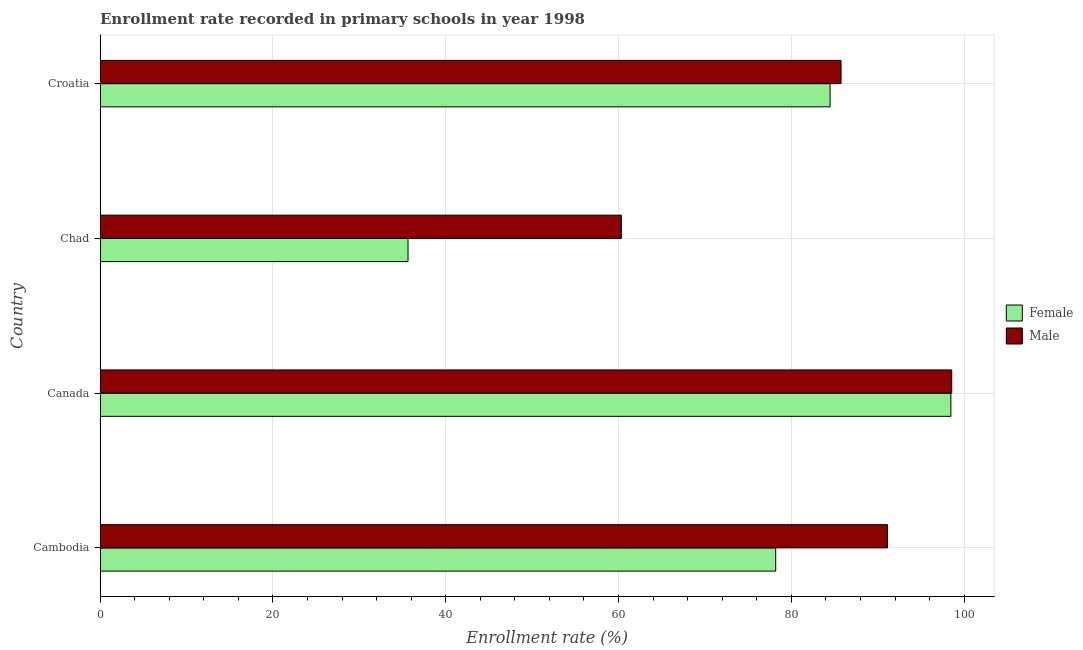How many groups of bars are there?
Make the answer very short. 4. How many bars are there on the 2nd tick from the top?
Provide a succinct answer. 2. What is the label of the 2nd group of bars from the top?
Your answer should be very brief. Chad. What is the enrollment rate of female students in Cambodia?
Your answer should be compact. 78.18. Across all countries, what is the maximum enrollment rate of male students?
Your response must be concise. 98.55. Across all countries, what is the minimum enrollment rate of female students?
Give a very brief answer. 35.64. In which country was the enrollment rate of male students maximum?
Your response must be concise. Canada. In which country was the enrollment rate of female students minimum?
Your response must be concise. Chad. What is the total enrollment rate of female students in the graph?
Offer a terse response. 296.76. What is the difference between the enrollment rate of male students in Cambodia and that in Chad?
Your response must be concise. 30.8. What is the difference between the enrollment rate of female students in Canada and the enrollment rate of male students in Cambodia?
Provide a succinct answer. 7.33. What is the average enrollment rate of male students per country?
Offer a terse response. 83.94. What is the difference between the enrollment rate of male students and enrollment rate of female students in Croatia?
Your answer should be compact. 1.27. In how many countries, is the enrollment rate of female students greater than 68 %?
Your response must be concise. 3. What is the ratio of the enrollment rate of male students in Cambodia to that in Croatia?
Your answer should be compact. 1.06. Is the difference between the enrollment rate of female students in Cambodia and Croatia greater than the difference between the enrollment rate of male students in Cambodia and Croatia?
Your response must be concise. No. What is the difference between the highest and the second highest enrollment rate of female students?
Your answer should be compact. 13.98. What is the difference between the highest and the lowest enrollment rate of female students?
Your response must be concise. 62.82. What does the 1st bar from the top in Cambodia represents?
Provide a short and direct response. Male. What does the 2nd bar from the bottom in Chad represents?
Ensure brevity in your answer.  Male. How many countries are there in the graph?
Give a very brief answer. 4. Where does the legend appear in the graph?
Your answer should be very brief. Center right. What is the title of the graph?
Keep it short and to the point. Enrollment rate recorded in primary schools in year 1998. What is the label or title of the X-axis?
Offer a very short reply. Enrollment rate (%). What is the label or title of the Y-axis?
Your answer should be compact. Country. What is the Enrollment rate (%) of Female in Cambodia?
Your answer should be compact. 78.18. What is the Enrollment rate (%) in Male in Cambodia?
Your answer should be very brief. 91.13. What is the Enrollment rate (%) of Female in Canada?
Ensure brevity in your answer.  98.46. What is the Enrollment rate (%) in Male in Canada?
Offer a very short reply. 98.55. What is the Enrollment rate (%) in Female in Chad?
Provide a short and direct response. 35.64. What is the Enrollment rate (%) in Male in Chad?
Offer a very short reply. 60.32. What is the Enrollment rate (%) of Female in Croatia?
Offer a terse response. 84.48. What is the Enrollment rate (%) in Male in Croatia?
Your answer should be very brief. 85.75. Across all countries, what is the maximum Enrollment rate (%) in Female?
Make the answer very short. 98.46. Across all countries, what is the maximum Enrollment rate (%) of Male?
Provide a succinct answer. 98.55. Across all countries, what is the minimum Enrollment rate (%) in Female?
Offer a terse response. 35.64. Across all countries, what is the minimum Enrollment rate (%) of Male?
Keep it short and to the point. 60.32. What is the total Enrollment rate (%) in Female in the graph?
Provide a short and direct response. 296.76. What is the total Enrollment rate (%) of Male in the graph?
Offer a terse response. 335.75. What is the difference between the Enrollment rate (%) of Female in Cambodia and that in Canada?
Ensure brevity in your answer.  -20.27. What is the difference between the Enrollment rate (%) of Male in Cambodia and that in Canada?
Provide a short and direct response. -7.43. What is the difference between the Enrollment rate (%) in Female in Cambodia and that in Chad?
Offer a terse response. 42.55. What is the difference between the Enrollment rate (%) in Male in Cambodia and that in Chad?
Provide a succinct answer. 30.8. What is the difference between the Enrollment rate (%) in Female in Cambodia and that in Croatia?
Provide a short and direct response. -6.3. What is the difference between the Enrollment rate (%) in Male in Cambodia and that in Croatia?
Your answer should be compact. 5.38. What is the difference between the Enrollment rate (%) in Female in Canada and that in Chad?
Provide a short and direct response. 62.82. What is the difference between the Enrollment rate (%) of Male in Canada and that in Chad?
Your answer should be compact. 38.23. What is the difference between the Enrollment rate (%) of Female in Canada and that in Croatia?
Offer a terse response. 13.98. What is the difference between the Enrollment rate (%) in Male in Canada and that in Croatia?
Ensure brevity in your answer.  12.81. What is the difference between the Enrollment rate (%) in Female in Chad and that in Croatia?
Your answer should be very brief. -48.84. What is the difference between the Enrollment rate (%) in Male in Chad and that in Croatia?
Your answer should be very brief. -25.42. What is the difference between the Enrollment rate (%) in Female in Cambodia and the Enrollment rate (%) in Male in Canada?
Your response must be concise. -20.37. What is the difference between the Enrollment rate (%) in Female in Cambodia and the Enrollment rate (%) in Male in Chad?
Offer a very short reply. 17.86. What is the difference between the Enrollment rate (%) of Female in Cambodia and the Enrollment rate (%) of Male in Croatia?
Ensure brevity in your answer.  -7.56. What is the difference between the Enrollment rate (%) of Female in Canada and the Enrollment rate (%) of Male in Chad?
Make the answer very short. 38.14. What is the difference between the Enrollment rate (%) in Female in Canada and the Enrollment rate (%) in Male in Croatia?
Provide a short and direct response. 12.71. What is the difference between the Enrollment rate (%) of Female in Chad and the Enrollment rate (%) of Male in Croatia?
Give a very brief answer. -50.11. What is the average Enrollment rate (%) of Female per country?
Provide a short and direct response. 74.19. What is the average Enrollment rate (%) in Male per country?
Provide a short and direct response. 83.94. What is the difference between the Enrollment rate (%) of Female and Enrollment rate (%) of Male in Cambodia?
Make the answer very short. -12.94. What is the difference between the Enrollment rate (%) of Female and Enrollment rate (%) of Male in Canada?
Make the answer very short. -0.1. What is the difference between the Enrollment rate (%) of Female and Enrollment rate (%) of Male in Chad?
Make the answer very short. -24.68. What is the difference between the Enrollment rate (%) in Female and Enrollment rate (%) in Male in Croatia?
Give a very brief answer. -1.27. What is the ratio of the Enrollment rate (%) of Female in Cambodia to that in Canada?
Offer a very short reply. 0.79. What is the ratio of the Enrollment rate (%) in Male in Cambodia to that in Canada?
Your response must be concise. 0.92. What is the ratio of the Enrollment rate (%) in Female in Cambodia to that in Chad?
Your response must be concise. 2.19. What is the ratio of the Enrollment rate (%) in Male in Cambodia to that in Chad?
Give a very brief answer. 1.51. What is the ratio of the Enrollment rate (%) in Female in Cambodia to that in Croatia?
Provide a short and direct response. 0.93. What is the ratio of the Enrollment rate (%) of Male in Cambodia to that in Croatia?
Offer a terse response. 1.06. What is the ratio of the Enrollment rate (%) in Female in Canada to that in Chad?
Provide a short and direct response. 2.76. What is the ratio of the Enrollment rate (%) in Male in Canada to that in Chad?
Your answer should be very brief. 1.63. What is the ratio of the Enrollment rate (%) of Female in Canada to that in Croatia?
Your answer should be compact. 1.17. What is the ratio of the Enrollment rate (%) of Male in Canada to that in Croatia?
Keep it short and to the point. 1.15. What is the ratio of the Enrollment rate (%) of Female in Chad to that in Croatia?
Provide a short and direct response. 0.42. What is the ratio of the Enrollment rate (%) in Male in Chad to that in Croatia?
Provide a short and direct response. 0.7. What is the difference between the highest and the second highest Enrollment rate (%) of Female?
Keep it short and to the point. 13.98. What is the difference between the highest and the second highest Enrollment rate (%) of Male?
Ensure brevity in your answer.  7.43. What is the difference between the highest and the lowest Enrollment rate (%) in Female?
Make the answer very short. 62.82. What is the difference between the highest and the lowest Enrollment rate (%) in Male?
Provide a short and direct response. 38.23. 